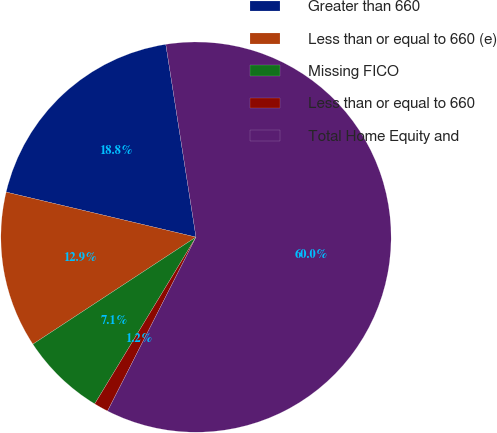Convert chart to OTSL. <chart><loc_0><loc_0><loc_500><loc_500><pie_chart><fcel>Greater than 660<fcel>Less than or equal to 660 (e)<fcel>Missing FICO<fcel>Less than or equal to 660<fcel>Total Home Equity and<nl><fcel>18.82%<fcel>12.95%<fcel>7.07%<fcel>1.2%<fcel>59.96%<nl></chart> 